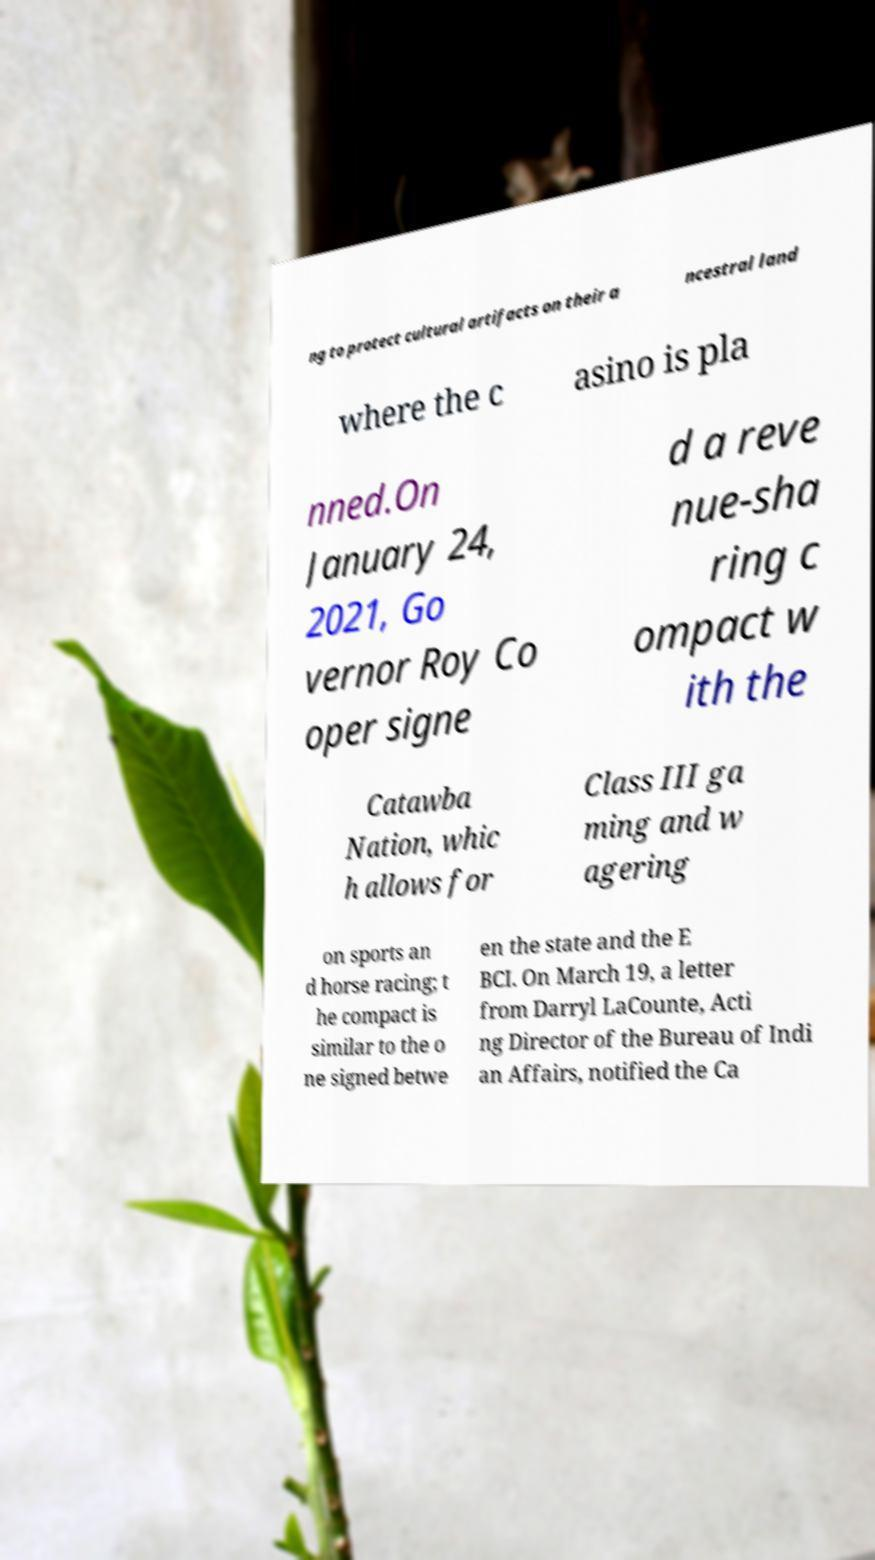Please identify and transcribe the text found in this image. ng to protect cultural artifacts on their a ncestral land where the c asino is pla nned.On January 24, 2021, Go vernor Roy Co oper signe d a reve nue-sha ring c ompact w ith the Catawba Nation, whic h allows for Class III ga ming and w agering on sports an d horse racing; t he compact is similar to the o ne signed betwe en the state and the E BCI. On March 19, a letter from Darryl LaCounte, Acti ng Director of the Bureau of Indi an Affairs, notified the Ca 